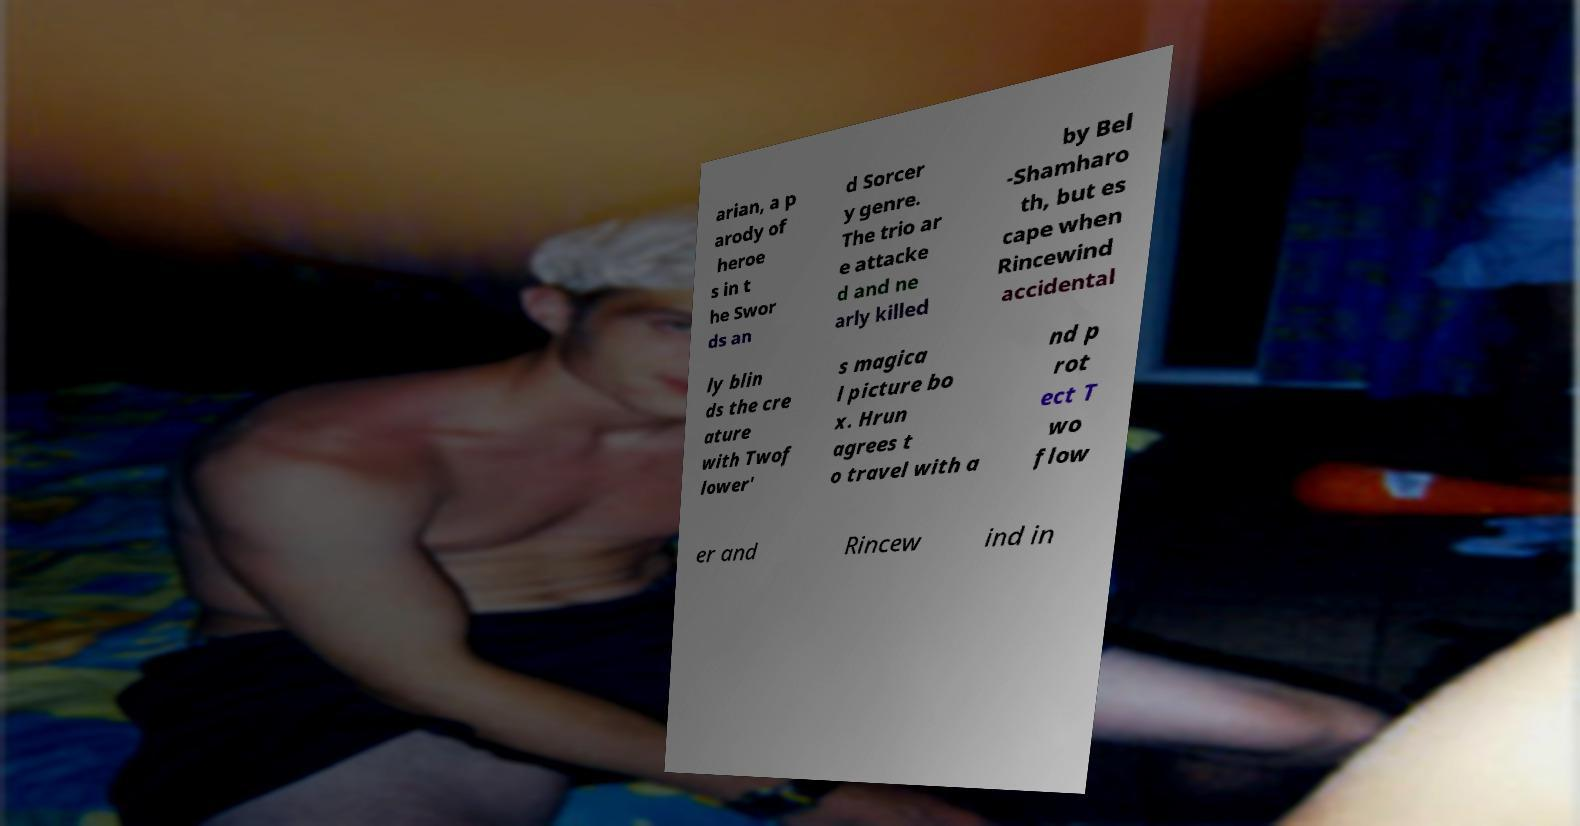There's text embedded in this image that I need extracted. Can you transcribe it verbatim? arian, a p arody of heroe s in t he Swor ds an d Sorcer y genre. The trio ar e attacke d and ne arly killed by Bel -Shamharo th, but es cape when Rincewind accidental ly blin ds the cre ature with Twof lower' s magica l picture bo x. Hrun agrees t o travel with a nd p rot ect T wo flow er and Rincew ind in 